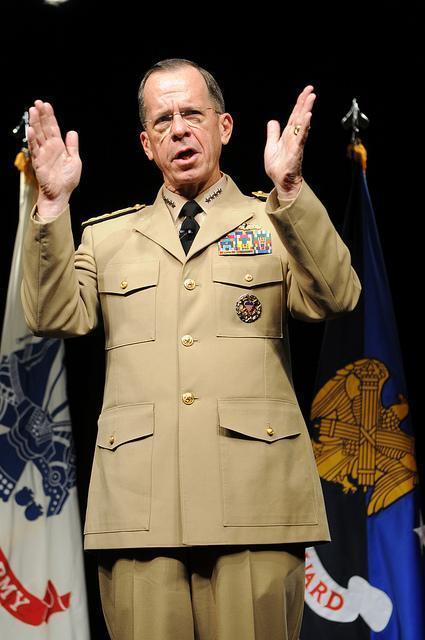How many donuts have blue color cream?
Give a very brief answer. 0. 